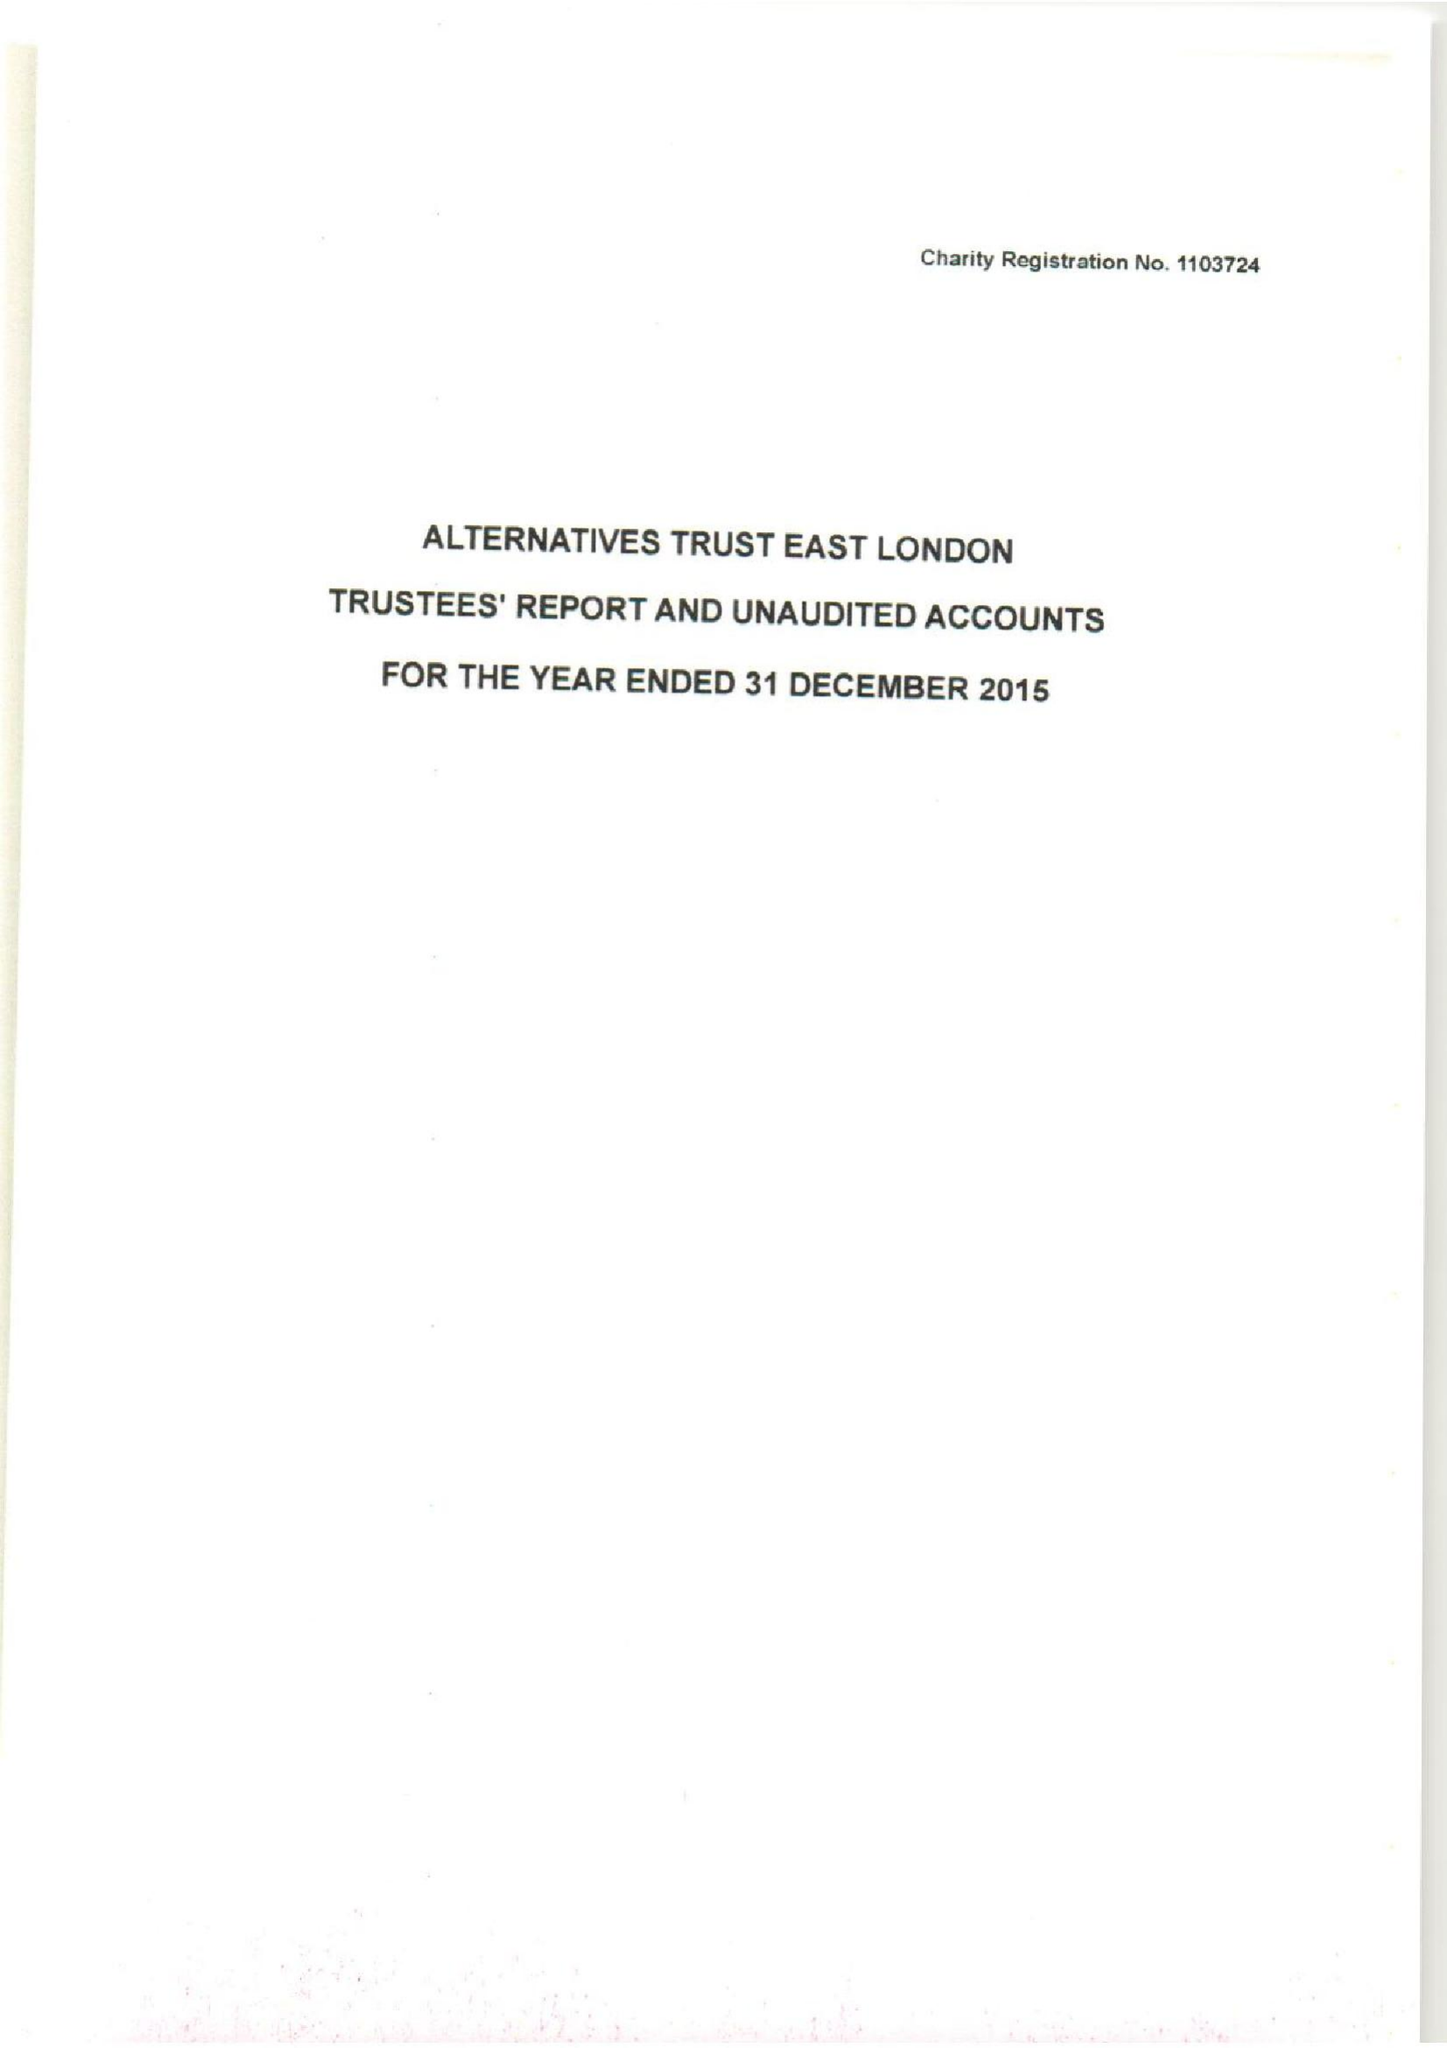What is the value for the address__street_line?
Answer the question using a single word or phrase. 63 ROWNTREE CLIFFORD CLOSE 